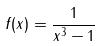<formula> <loc_0><loc_0><loc_500><loc_500>f ( x ) = \frac { 1 } { x ^ { 3 } - 1 }</formula> 